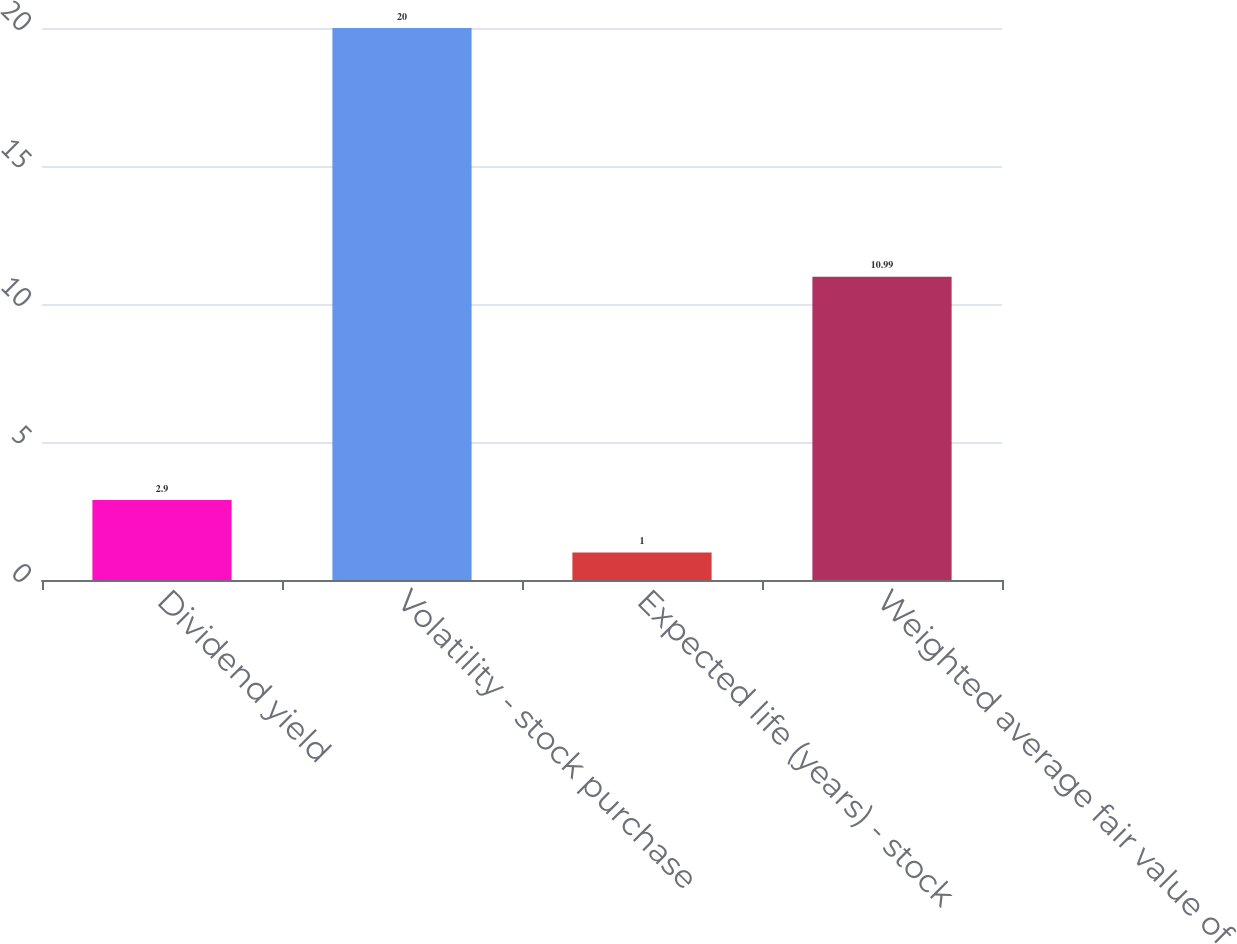Convert chart to OTSL. <chart><loc_0><loc_0><loc_500><loc_500><bar_chart><fcel>Dividend yield<fcel>Volatility - stock purchase<fcel>Expected life (years) - stock<fcel>Weighted average fair value of<nl><fcel>2.9<fcel>20<fcel>1<fcel>10.99<nl></chart> 